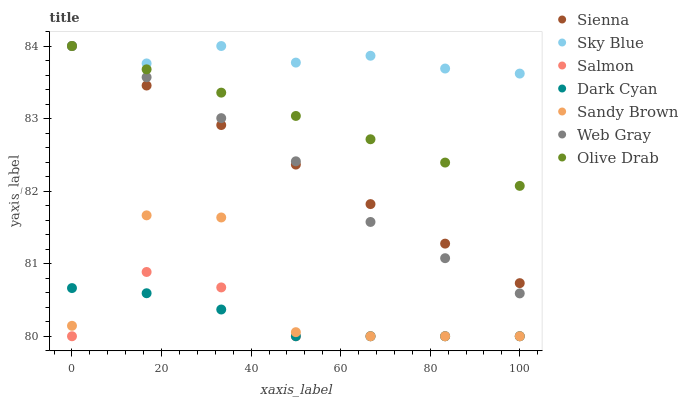Does Dark Cyan have the minimum area under the curve?
Answer yes or no. Yes. Does Sky Blue have the maximum area under the curve?
Answer yes or no. Yes. Does Salmon have the minimum area under the curve?
Answer yes or no. No. Does Salmon have the maximum area under the curve?
Answer yes or no. No. Is Olive Drab the smoothest?
Answer yes or no. Yes. Is Sandy Brown the roughest?
Answer yes or no. Yes. Is Salmon the smoothest?
Answer yes or no. No. Is Salmon the roughest?
Answer yes or no. No. Does Salmon have the lowest value?
Answer yes or no. Yes. Does Sienna have the lowest value?
Answer yes or no. No. Does Olive Drab have the highest value?
Answer yes or no. Yes. Does Salmon have the highest value?
Answer yes or no. No. Is Salmon less than Olive Drab?
Answer yes or no. Yes. Is Olive Drab greater than Sandy Brown?
Answer yes or no. Yes. Does Olive Drab intersect Web Gray?
Answer yes or no. Yes. Is Olive Drab less than Web Gray?
Answer yes or no. No. Is Olive Drab greater than Web Gray?
Answer yes or no. No. Does Salmon intersect Olive Drab?
Answer yes or no. No. 